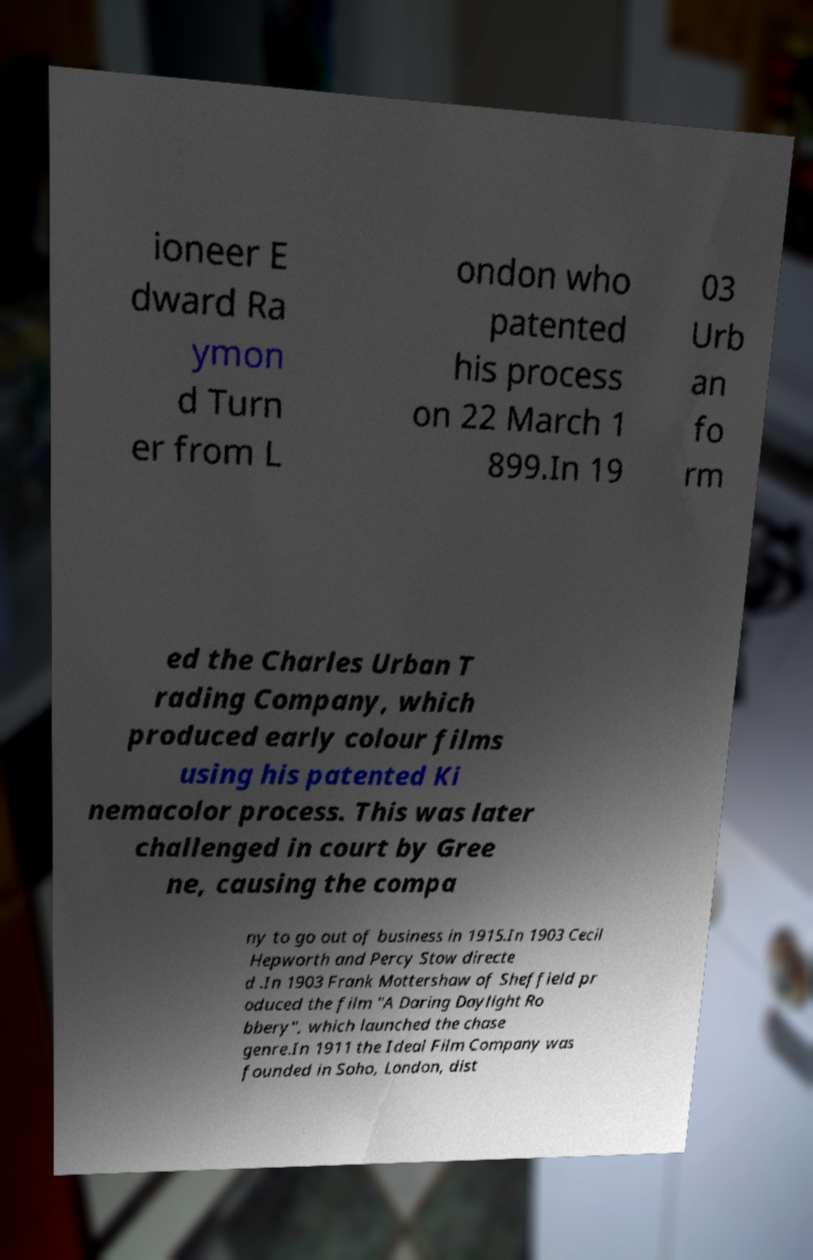What messages or text are displayed in this image? I need them in a readable, typed format. ioneer E dward Ra ymon d Turn er from L ondon who patented his process on 22 March 1 899.In 19 03 Urb an fo rm ed the Charles Urban T rading Company, which produced early colour films using his patented Ki nemacolor process. This was later challenged in court by Gree ne, causing the compa ny to go out of business in 1915.In 1903 Cecil Hepworth and Percy Stow directe d .In 1903 Frank Mottershaw of Sheffield pr oduced the film "A Daring Daylight Ro bbery", which launched the chase genre.In 1911 the Ideal Film Company was founded in Soho, London, dist 